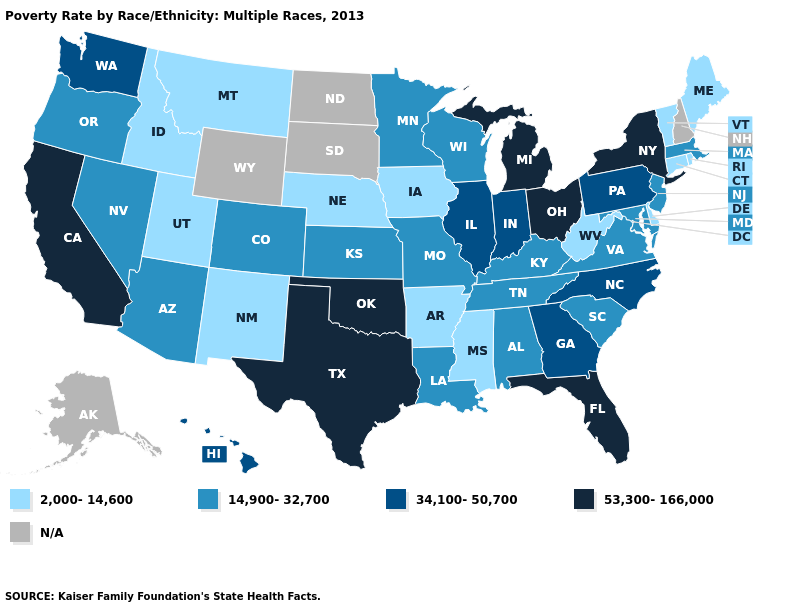What is the value of Florida?
Short answer required. 53,300-166,000. What is the lowest value in states that border Kentucky?
Quick response, please. 2,000-14,600. Among the states that border Texas , which have the lowest value?
Write a very short answer. Arkansas, New Mexico. What is the value of Minnesota?
Be succinct. 14,900-32,700. Does Delaware have the lowest value in the South?
Concise answer only. Yes. What is the highest value in the Northeast ?
Be succinct. 53,300-166,000. What is the value of Montana?
Short answer required. 2,000-14,600. Which states have the lowest value in the USA?
Be succinct. Arkansas, Connecticut, Delaware, Idaho, Iowa, Maine, Mississippi, Montana, Nebraska, New Mexico, Rhode Island, Utah, Vermont, West Virginia. Which states have the lowest value in the USA?
Answer briefly. Arkansas, Connecticut, Delaware, Idaho, Iowa, Maine, Mississippi, Montana, Nebraska, New Mexico, Rhode Island, Utah, Vermont, West Virginia. Does the first symbol in the legend represent the smallest category?
Write a very short answer. Yes. What is the value of Utah?
Be succinct. 2,000-14,600. Which states have the highest value in the USA?
Keep it brief. California, Florida, Michigan, New York, Ohio, Oklahoma, Texas. Among the states that border Utah , which have the lowest value?
Be succinct. Idaho, New Mexico. Name the states that have a value in the range 34,100-50,700?
Write a very short answer. Georgia, Hawaii, Illinois, Indiana, North Carolina, Pennsylvania, Washington. 